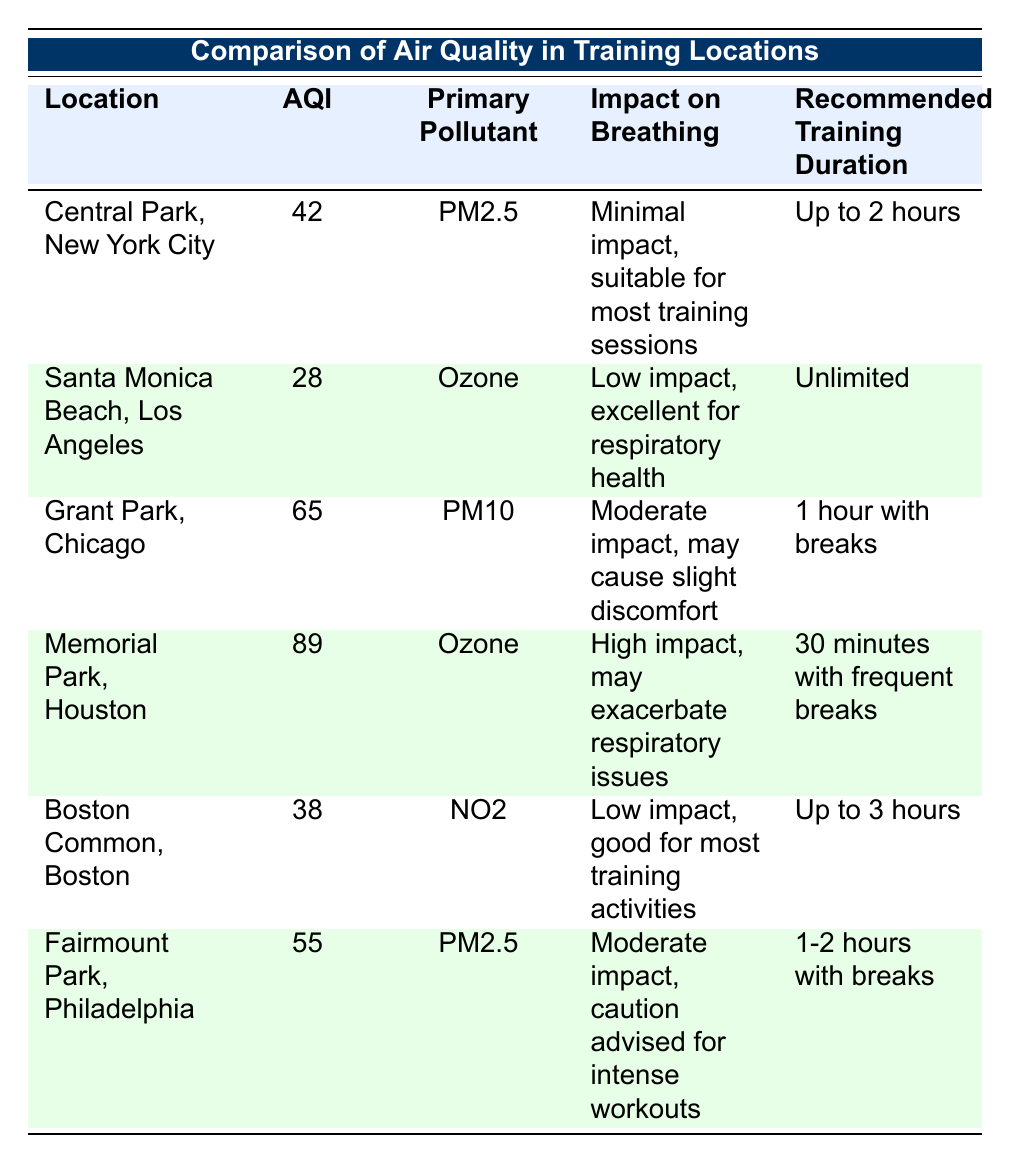What is the air quality index (AQI) of Central Park, New York City? The table lists the AQI for Central Park, New York City, which is 42. This is a direct retrieval from the specific row corresponding to Central Park.
Answer: 42 Which location has the lowest air quality index (AQI)? In the table, upon checking all the listed AQIs, Santa Monica Beach, Los Angeles has the lowest AQI, which is 28. This required comparing each AQI value from the locations.
Answer: Santa Monica Beach, Los Angeles Is training at Memorial Park, Houston recommended for more than 30 minutes? The table states that the recommended training duration for Memorial Park, Houston is 30 minutes with frequent breaks. Therefore, it is not recommended for continuous training beyond this duration.
Answer: No What is the primary pollutant at Fairmount Park, Philadelphia? The primary pollutant for Fairmount Park, Philadelphia is listed in the table as PM2.5. This information is obtained directly from the corresponding row.
Answer: PM2.5 If I train for 1 hour at Grant Park, Chicago, how long should I take breaks compared to the training session? The table mentions that for training at Grant Park, Chicago, the recommended duration is 1 hour with breaks. Therefore, the training is equal to the time spent training, which would imply breaks can be whatever time is comfortable but should ideally be taken periodically rather than quantified exactly.
Answer: Breaks can be comfortable Which two locations have low impact on breathing according to the table? The table indicates that both Santa Monica Beach, Los Angeles and Boston Common, Boston have low impact on breathing, with Santa Monica Beach having 'low impact, excellent for respiratory health' and Boston Common having 'low impact, good for most training activities.' Thus, combining these direct statements leads to the answer.
Answer: Santa Monica Beach, Los Angeles and Boston Common, Boston What is the average air quality index (AQI) of the locations with moderate impact on breathing? The moderate impact locations are Grant Park, Chicago (65) and Fairmount Park, Philadelphia (55). To find the average AQI, we sum these AQIs: 65 + 55 = 120, and then divide by 2 (the number of locations): 120 / 2 = 60. This entails identification of the specific rows with moderate breathing impact and then performing arithmetic operations.
Answer: 60 Is the air quality better in Santa Monica Beach, Los Angeles, compared to Memorial Park, Houston? Looking at the AQI values, Santa Monica Beach has an AQI of 28, while Memorial Park has an AQI of 89. Since 28 is less than 89, it indicates that air quality in Santa Monica Beach is indeed better. Thus, checking the respective AQIs from the table provides the answer.
Answer: Yes What training duration is recommended at Boston Common, Boston? The table shows that the recommended training duration at Boston Common, Boston is 'Up to 3 hours.' This is a straightforward retrieval from the entry for Boston Common.
Answer: Up to 3 hours 